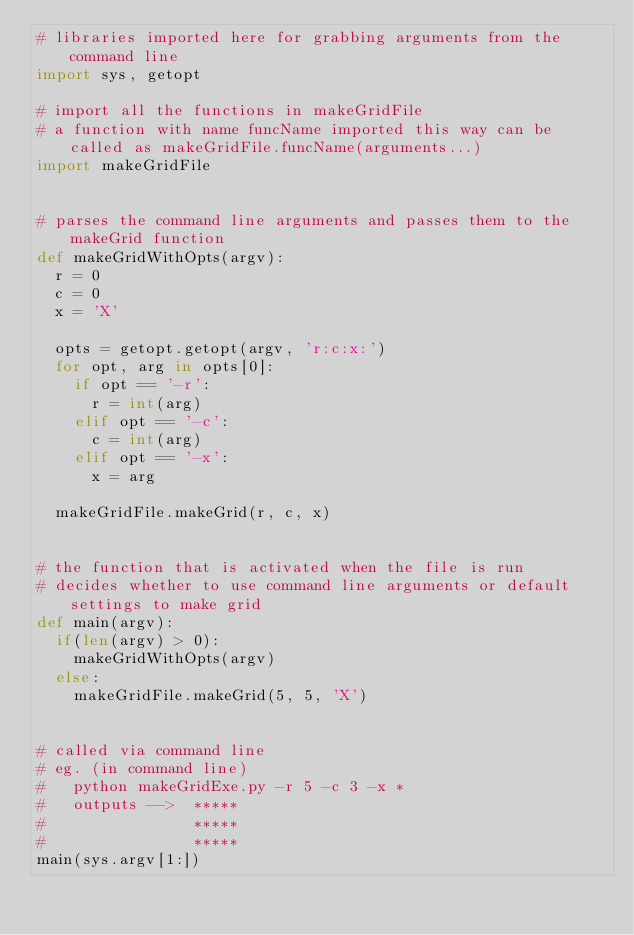<code> <loc_0><loc_0><loc_500><loc_500><_Python_># libraries imported here for grabbing arguments from the command line
import sys, getopt

# import all the functions in makeGridFile
# a function with name funcName imported this way can be called as makeGridFile.funcName(arguments...)
import makeGridFile


# parses the command line arguments and passes them to the makeGrid function
def makeGridWithOpts(argv):
  r = 0
  c = 0
  x = 'X'
  
  opts = getopt.getopt(argv, 'r:c:x:')
  for opt, arg in opts[0]:
    if opt == '-r':
      r = int(arg)
    elif opt == '-c':
      c = int(arg)
    elif opt == '-x':
      x = arg
  
  makeGridFile.makeGrid(r, c, x)


# the function that is activated when the file is run
# decides whether to use command line arguments or default settings to make grid
def main(argv):
  if(len(argv) > 0):
    makeGridWithOpts(argv)
  else:
    makeGridFile.makeGrid(5, 5, 'X')


# called via command line
# eg. (in command line)
#   python makeGridExe.py -r 5 -c 3 -x *
#   outputs -->  *****
#                *****
#                *****
main(sys.argv[1:])</code> 